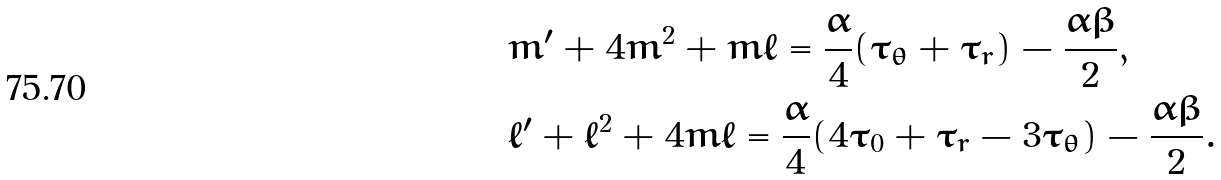Convert formula to latex. <formula><loc_0><loc_0><loc_500><loc_500>& m ^ { \prime } + 4 m ^ { 2 } + m \ell = \frac { \alpha } { 4 } ( \tau _ { \theta } + \tau _ { r } ) - \frac { \alpha \beta } { 2 } , \\ & \ell ^ { \prime } + \ell ^ { 2 } + 4 m \ell = \frac { \alpha } { 4 } ( 4 \tau _ { 0 } + \tau _ { r } - 3 \tau _ { \theta } ) - \frac { \alpha \beta } { 2 } .</formula> 